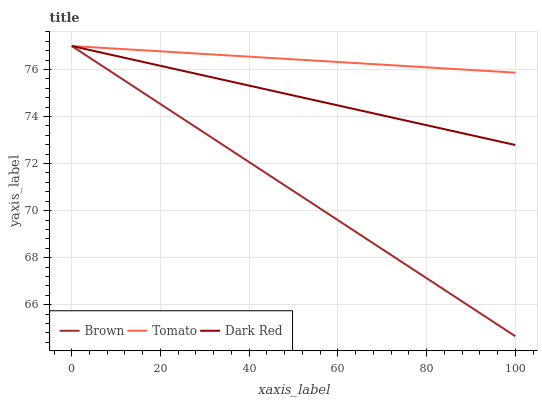Does Brown have the minimum area under the curve?
Answer yes or no. Yes. Does Tomato have the maximum area under the curve?
Answer yes or no. Yes. Does Dark Red have the minimum area under the curve?
Answer yes or no. No. Does Dark Red have the maximum area under the curve?
Answer yes or no. No. Is Dark Red the smoothest?
Answer yes or no. Yes. Is Brown the roughest?
Answer yes or no. Yes. Is Brown the smoothest?
Answer yes or no. No. Is Dark Red the roughest?
Answer yes or no. No. Does Brown have the lowest value?
Answer yes or no. Yes. Does Dark Red have the lowest value?
Answer yes or no. No. Does Dark Red have the highest value?
Answer yes or no. Yes. Does Tomato intersect Brown?
Answer yes or no. Yes. Is Tomato less than Brown?
Answer yes or no. No. Is Tomato greater than Brown?
Answer yes or no. No. 